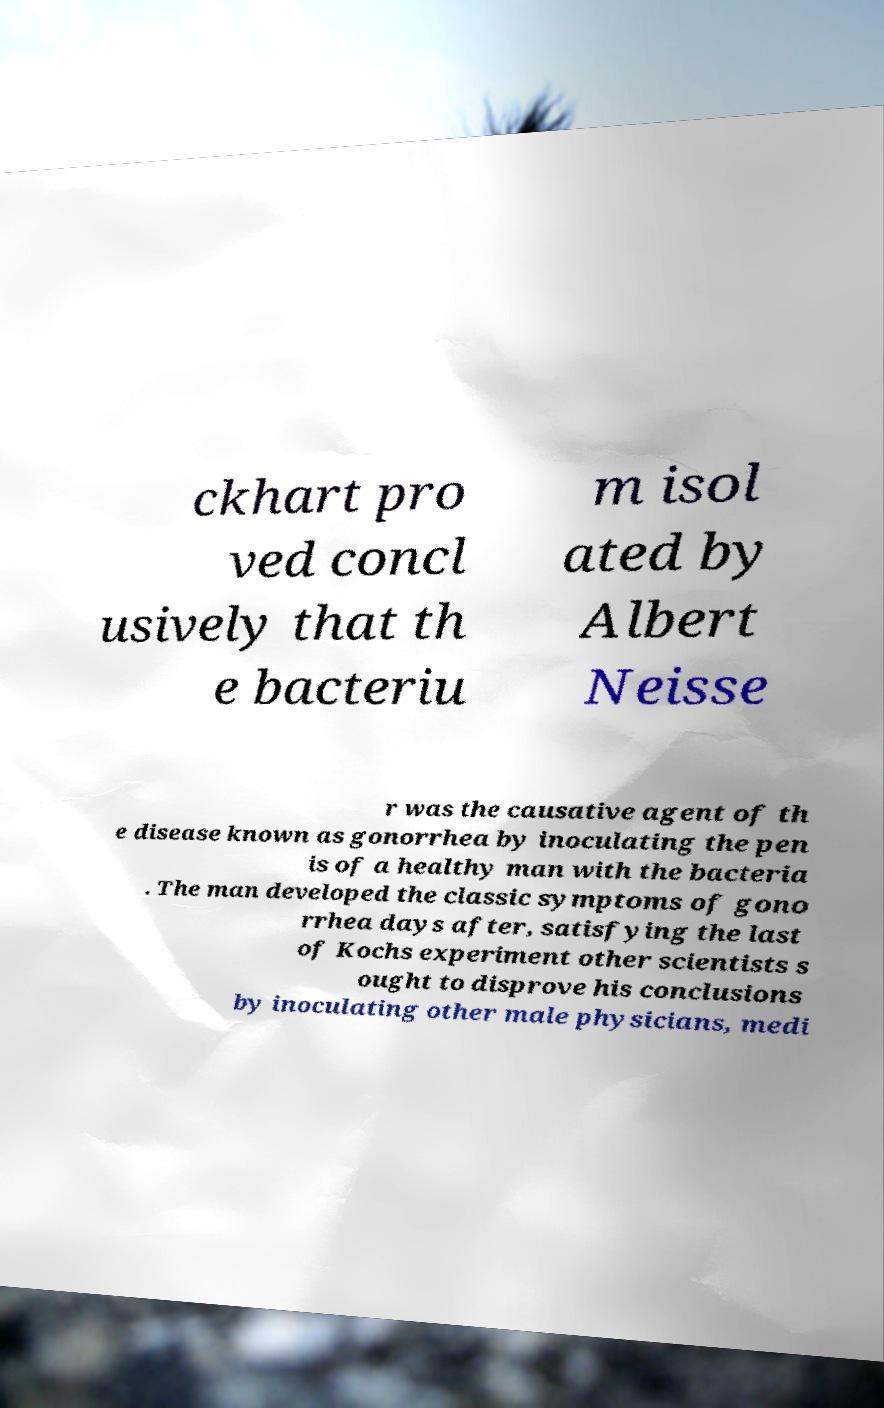I need the written content from this picture converted into text. Can you do that? ckhart pro ved concl usively that th e bacteriu m isol ated by Albert Neisse r was the causative agent of th e disease known as gonorrhea by inoculating the pen is of a healthy man with the bacteria . The man developed the classic symptoms of gono rrhea days after, satisfying the last of Kochs experiment other scientists s ought to disprove his conclusions by inoculating other male physicians, medi 